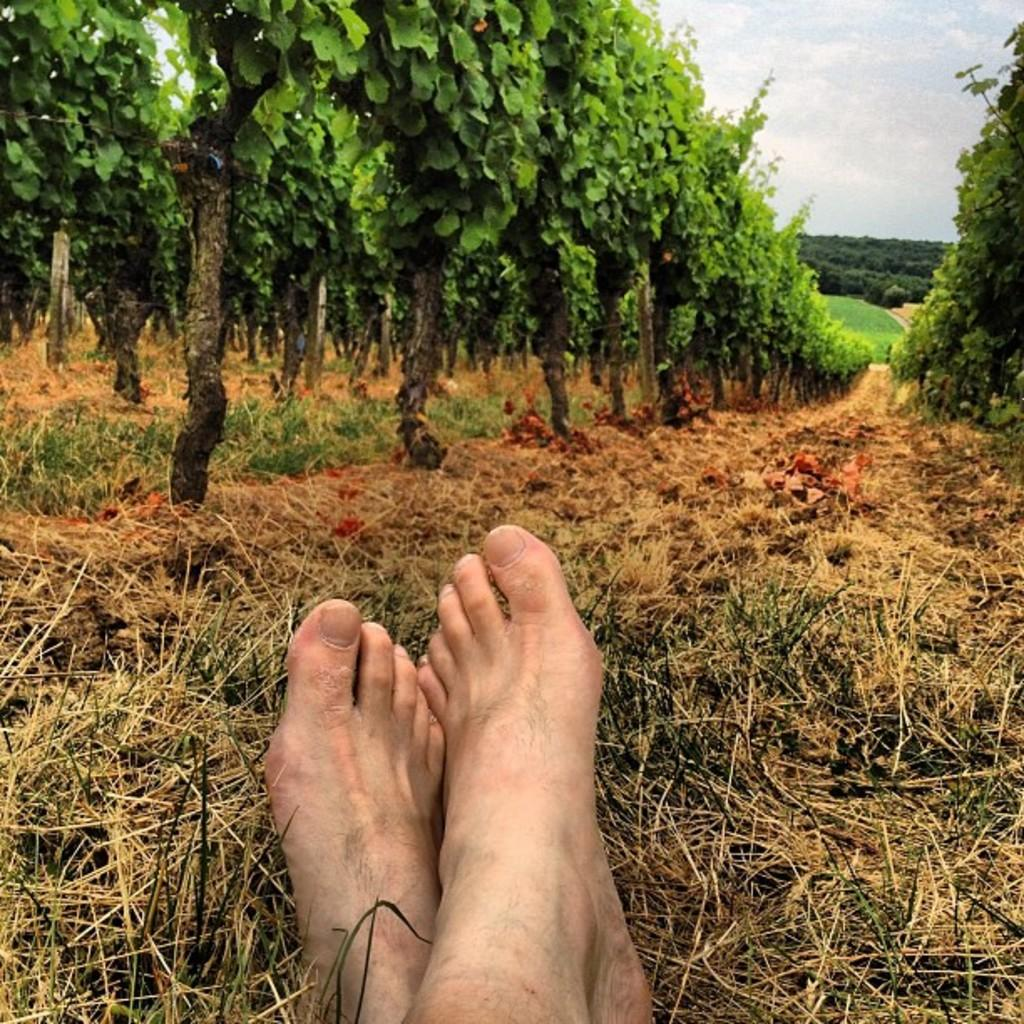What part of a person can be seen in the image? There is a foot of a person visible on the grassland. What type of plants are located near the foot? There are grape plants on either side of the foot. What is visible above the foot in the image? The sky is visible above the foot. What can be observed in the sky? Clouds are present in the sky. What time of day is it in the image, and what is the dad doing? The provided facts do not mention the time of day or the presence of a dad, so we cannot answer these questions based on the information given. 